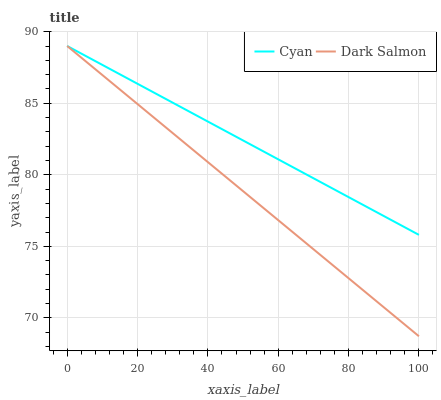Does Dark Salmon have the minimum area under the curve?
Answer yes or no. Yes. Does Cyan have the maximum area under the curve?
Answer yes or no. Yes. Does Dark Salmon have the maximum area under the curve?
Answer yes or no. No. Is Dark Salmon the smoothest?
Answer yes or no. Yes. Is Cyan the roughest?
Answer yes or no. Yes. Is Dark Salmon the roughest?
Answer yes or no. No. Does Dark Salmon have the highest value?
Answer yes or no. Yes. Does Dark Salmon intersect Cyan?
Answer yes or no. Yes. Is Dark Salmon less than Cyan?
Answer yes or no. No. Is Dark Salmon greater than Cyan?
Answer yes or no. No. 